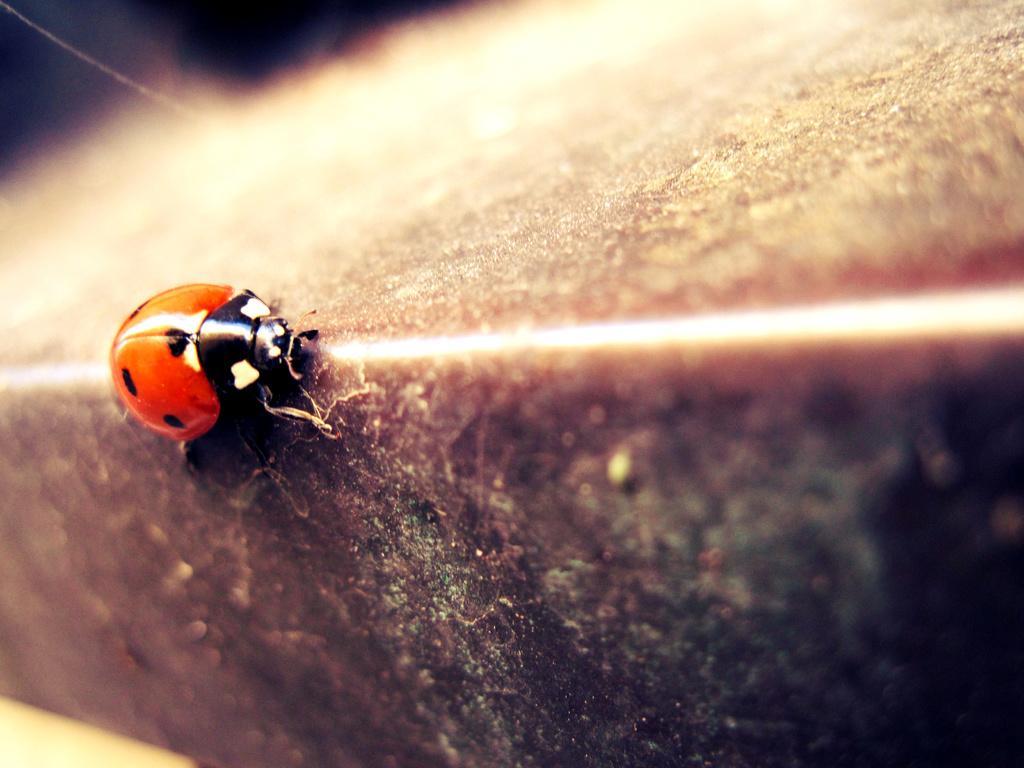Can you describe this image briefly? In the picture we can see an insect which is on surface. 